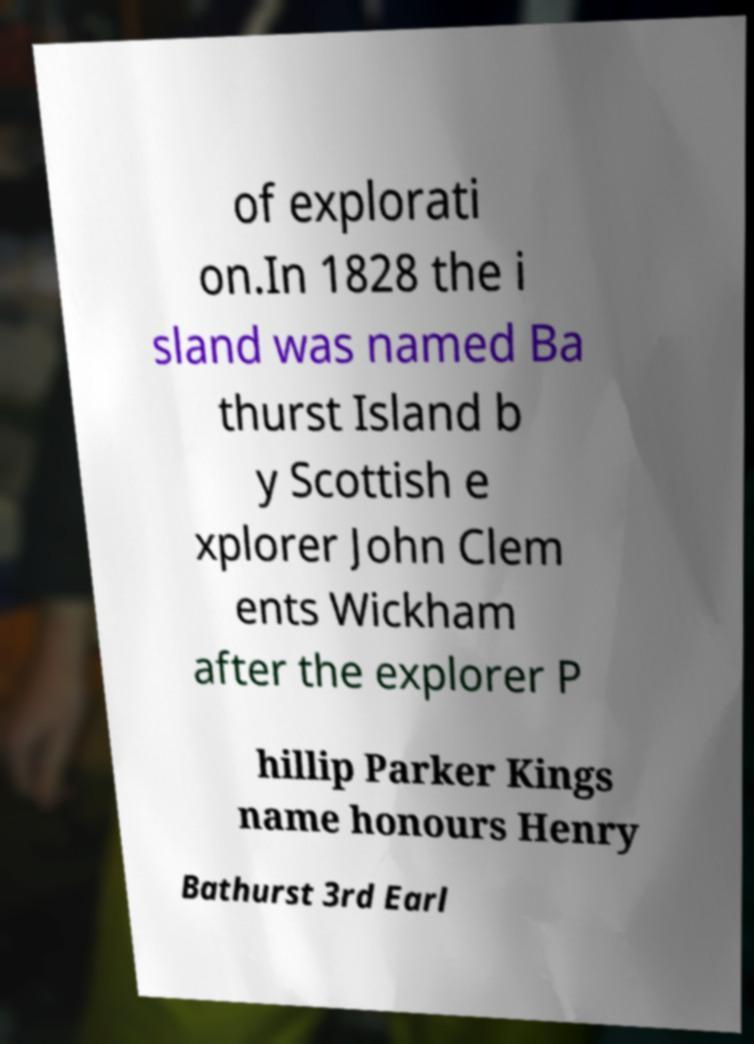Can you read and provide the text displayed in the image?This photo seems to have some interesting text. Can you extract and type it out for me? of explorati on.In 1828 the i sland was named Ba thurst Island b y Scottish e xplorer John Clem ents Wickham after the explorer P hillip Parker Kings name honours Henry Bathurst 3rd Earl 